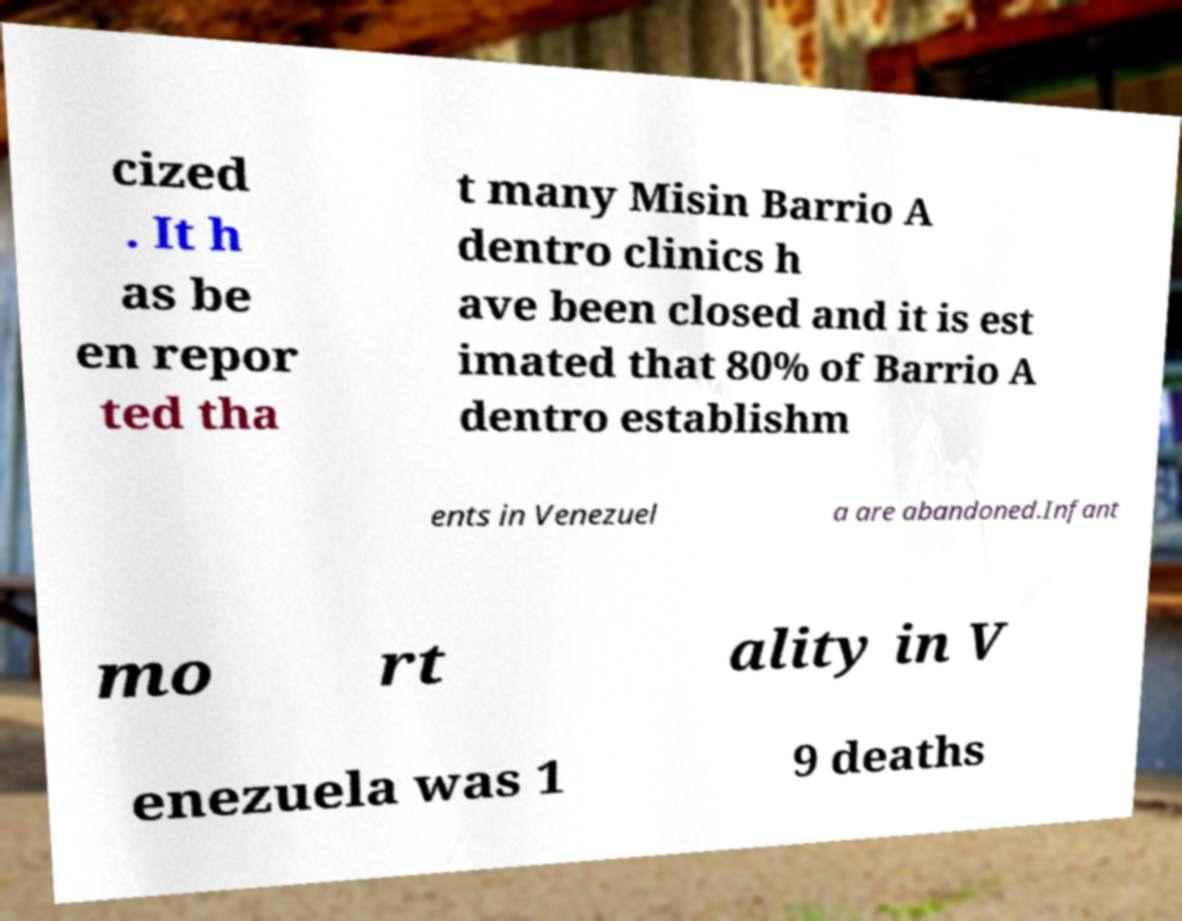Could you assist in decoding the text presented in this image and type it out clearly? cized . It h as be en repor ted tha t many Misin Barrio A dentro clinics h ave been closed and it is est imated that 80% of Barrio A dentro establishm ents in Venezuel a are abandoned.Infant mo rt ality in V enezuela was 1 9 deaths 